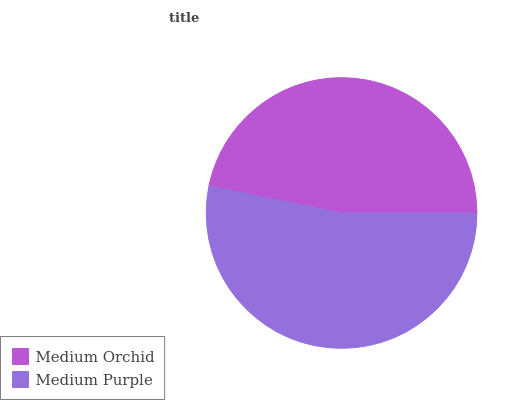Is Medium Orchid the minimum?
Answer yes or no. Yes. Is Medium Purple the maximum?
Answer yes or no. Yes. Is Medium Purple the minimum?
Answer yes or no. No. Is Medium Purple greater than Medium Orchid?
Answer yes or no. Yes. Is Medium Orchid less than Medium Purple?
Answer yes or no. Yes. Is Medium Orchid greater than Medium Purple?
Answer yes or no. No. Is Medium Purple less than Medium Orchid?
Answer yes or no. No. Is Medium Purple the high median?
Answer yes or no. Yes. Is Medium Orchid the low median?
Answer yes or no. Yes. Is Medium Orchid the high median?
Answer yes or no. No. Is Medium Purple the low median?
Answer yes or no. No. 